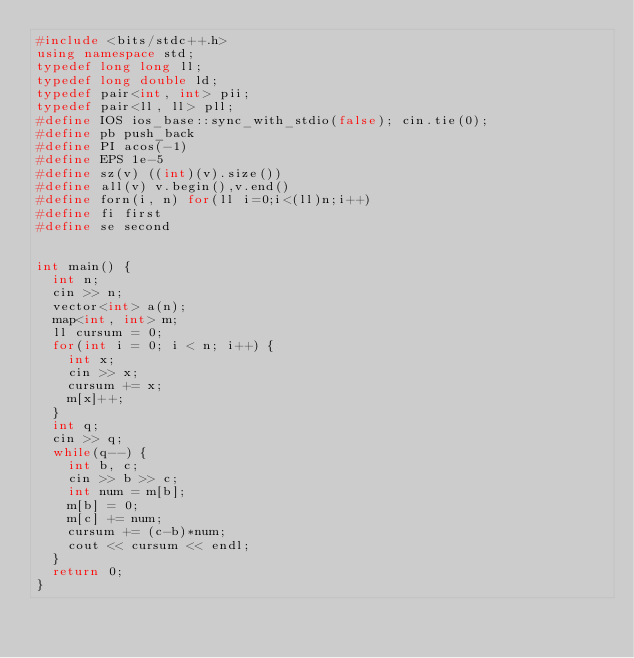Convert code to text. <code><loc_0><loc_0><loc_500><loc_500><_C++_>#include <bits/stdc++.h>
using namespace std;
typedef long long ll;
typedef long double ld;
typedef pair<int, int> pii;
typedef pair<ll, ll> pll;
#define IOS ios_base::sync_with_stdio(false); cin.tie(0);
#define pb push_back
#define PI acos(-1)
#define EPS 1e-5
#define sz(v) ((int)(v).size())
#define all(v) v.begin(),v.end()
#define forn(i, n) for(ll i=0;i<(ll)n;i++)
#define fi first
#define se second
 

int main() {
	int n;
	cin >> n;
	vector<int> a(n);
	map<int, int> m;
	ll cursum = 0;
	for(int i = 0; i < n; i++) {
		int x;
		cin >> x;
		cursum += x;
		m[x]++;
	}
	int q;
	cin >> q;
	while(q--) {
		int b, c;
		cin >> b >> c;
		int num = m[b];
		m[b] = 0;
		m[c] += num;
		cursum += (c-b)*num;
		cout << cursum << endl;
	}
	return 0;
}

</code> 